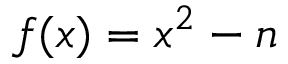Convert formula to latex. <formula><loc_0><loc_0><loc_500><loc_500>f ( x ) = x ^ { 2 } - n</formula> 